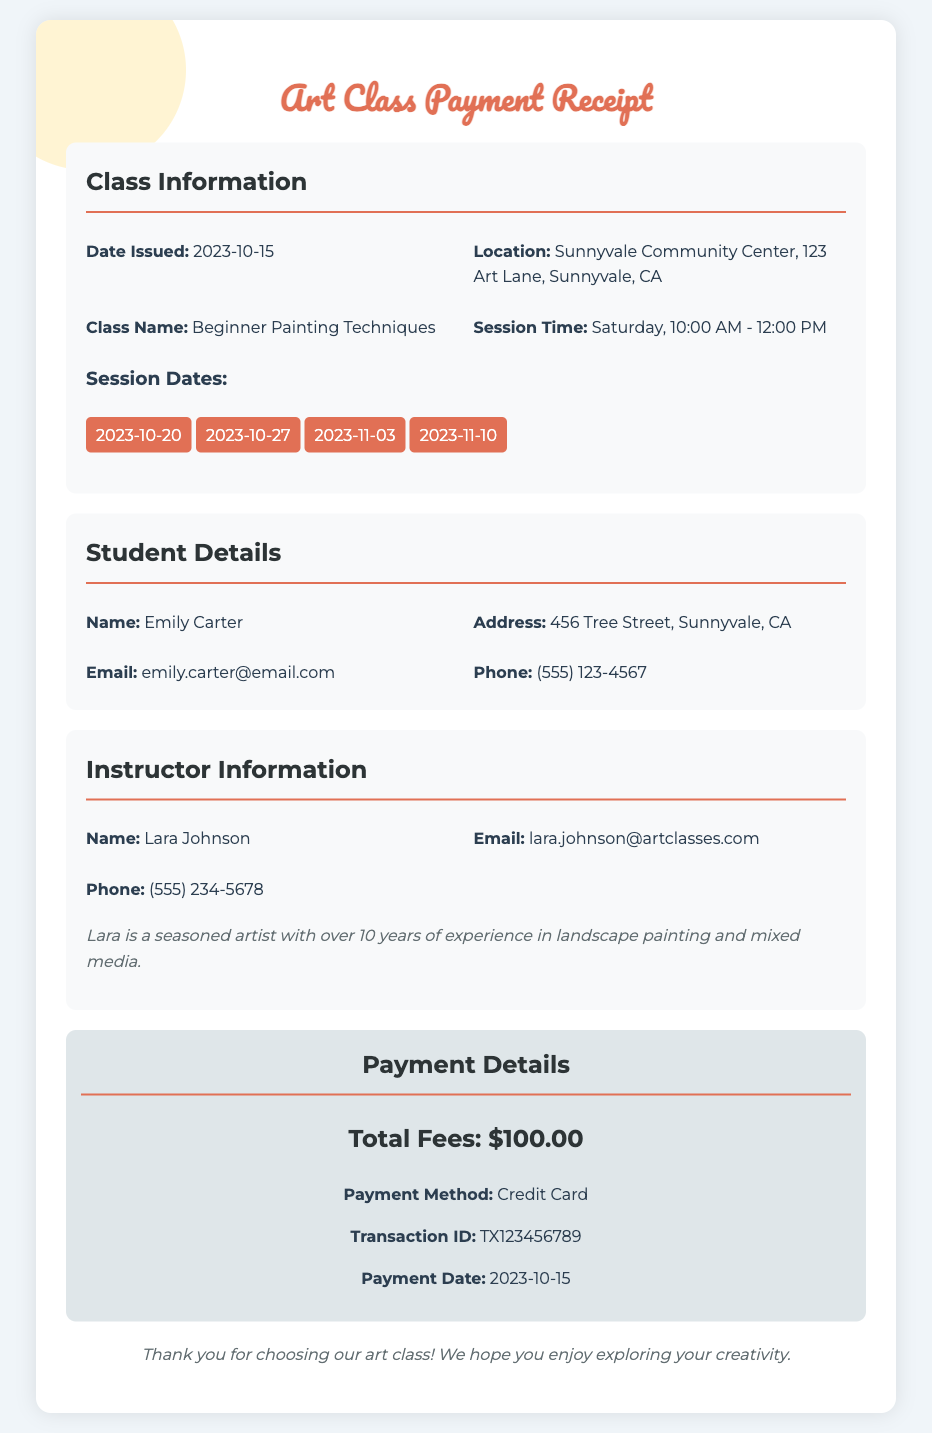what is the total fees? The total fees are listed in the payment details section of the document, which is $100.00.
Answer: $100.00 who is the instructor? The instructor's name is provided in the instructor information section of the document, which is Lara Johnson.
Answer: Lara Johnson when is the first session date? The first session date is listed under the session dates section, which is 2023-10-20.
Answer: 2023-10-20 what is the method of payment? The method of payment is mentioned in the payment details section, which is Credit Card.
Answer: Credit Card what is the student’s email address? The student's email is found in the student details section, listed as emily.carter@email.com.
Answer: emily.carter@email.com how many session dates are listed? The number of session dates can be counted from the session dates section, which lists four dates.
Answer: 4 what is the location of the art class? The location of the art class is specified in the class information section, which is Sunnyvale Community Center, 123 Art Lane, Sunnyvale, CA.
Answer: Sunnyvale Community Center, 123 Art Lane, Sunnyvale, CA what is the transaction ID? The transaction ID can be found in the payment details section, listed as TX123456789.
Answer: TX123456789 what is the class name? The class name is provided in the class information section of the document, which is Beginner Painting Techniques.
Answer: Beginner Painting Techniques 